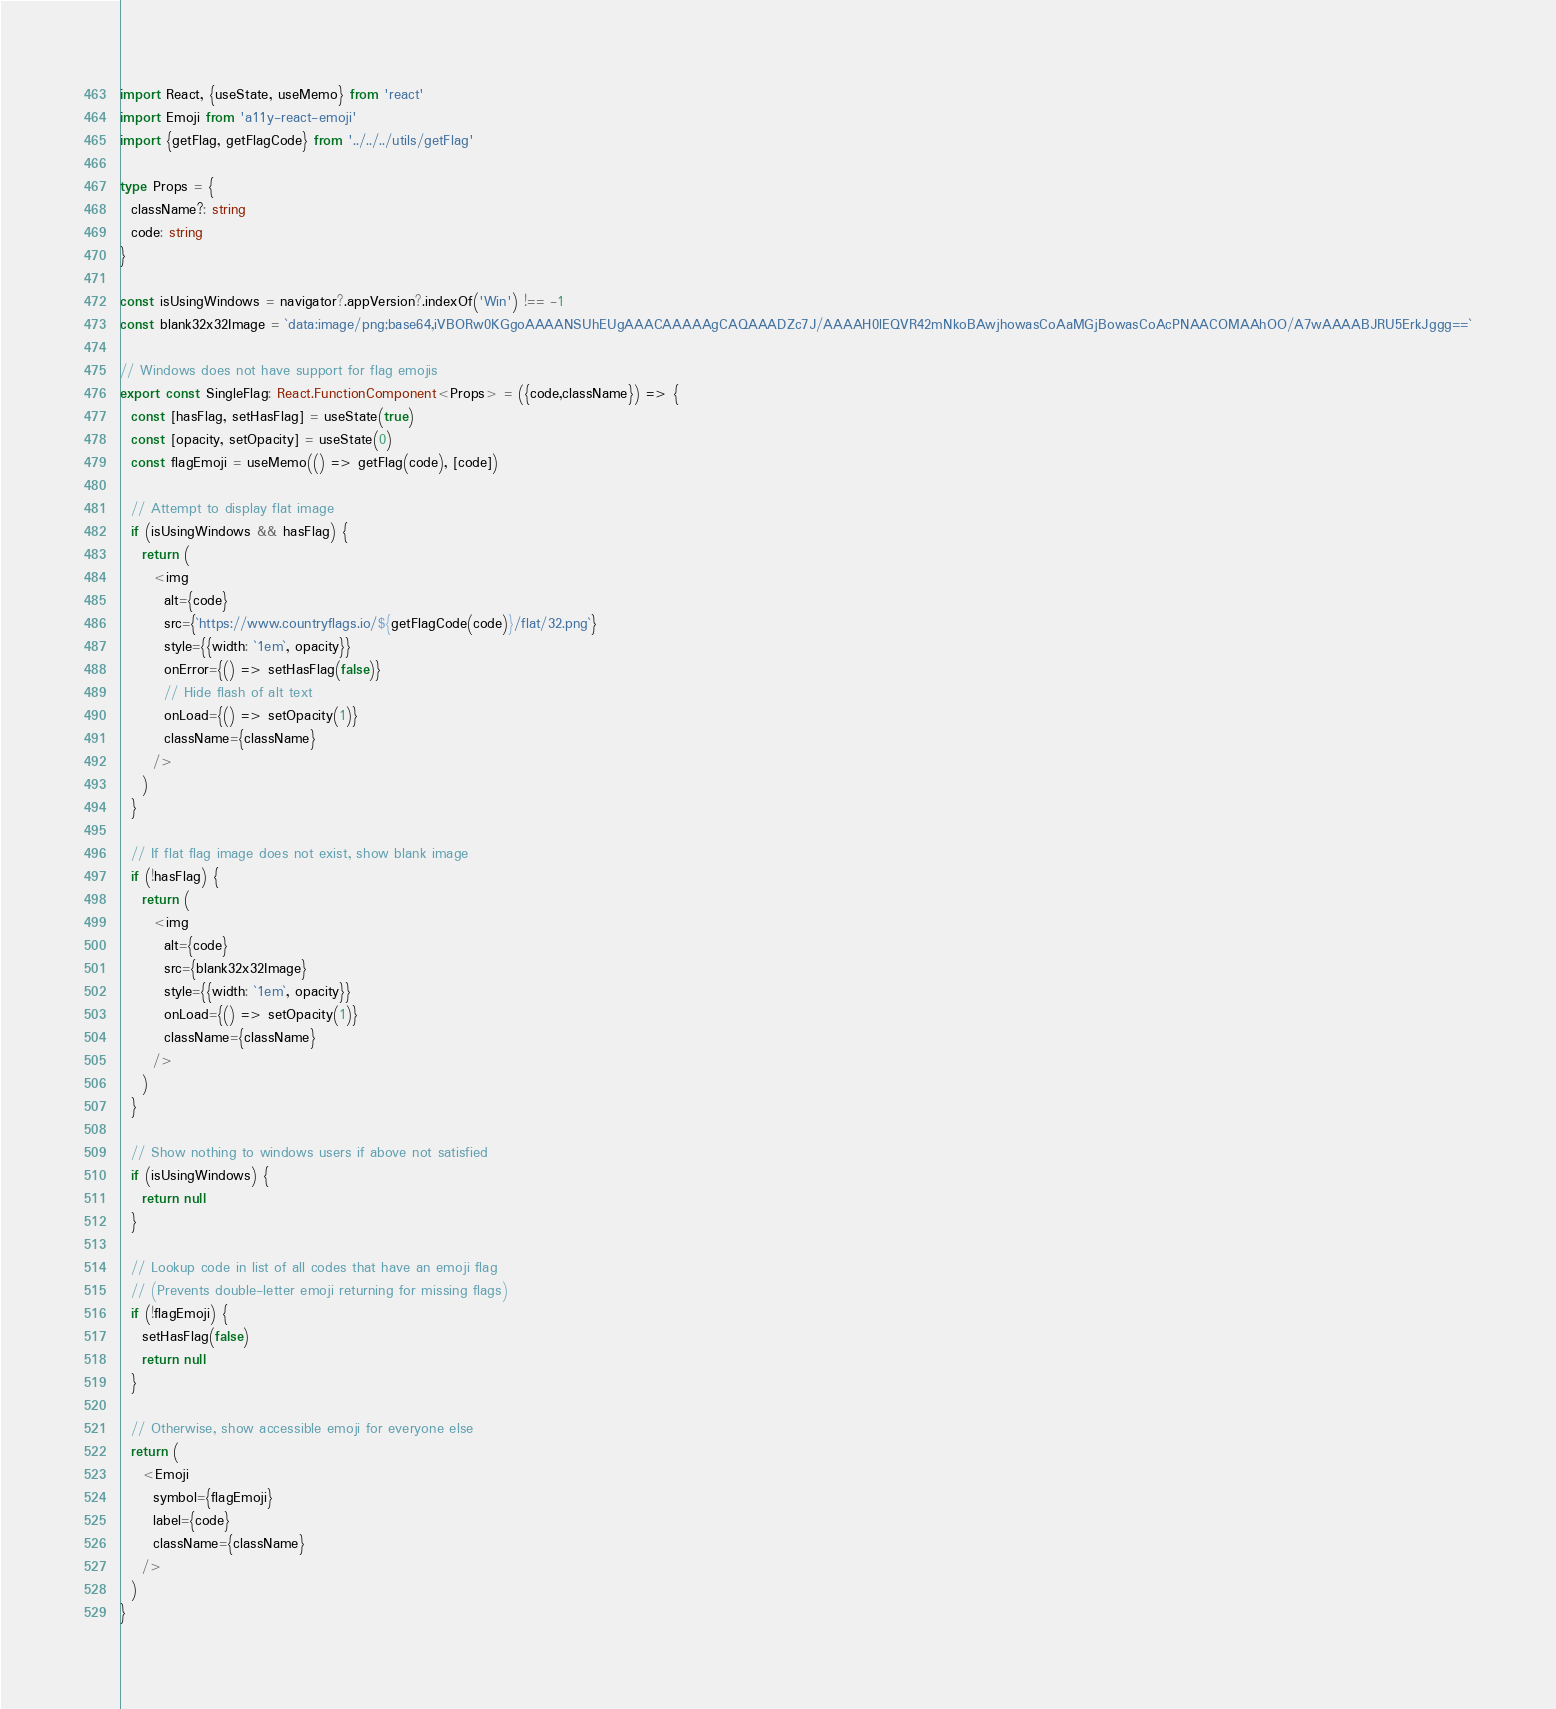<code> <loc_0><loc_0><loc_500><loc_500><_TypeScript_>import React, {useState, useMemo} from 'react'
import Emoji from 'a11y-react-emoji'
import {getFlag, getFlagCode} from '../../../utils/getFlag'

type Props = {
  className?: string
  code: string
}

const isUsingWindows = navigator?.appVersion?.indexOf('Win') !== -1
const blank32x32Image = `data:image/png;base64,iVBORw0KGgoAAAANSUhEUgAAACAAAAAgCAQAAADZc7J/AAAAH0lEQVR42mNkoBAwjhowasCoAaMGjBowasCoAcPNAACOMAAhOO/A7wAAAABJRU5ErkJggg==`

// Windows does not have support for flag emojis
export const SingleFlag: React.FunctionComponent<Props> = ({code,className}) => {
  const [hasFlag, setHasFlag] = useState(true)
  const [opacity, setOpacity] = useState(0)
  const flagEmoji = useMemo(() => getFlag(code), [code])

  // Attempt to display flat image
  if (isUsingWindows && hasFlag) {
    return (
      <img
        alt={code}
        src={`https://www.countryflags.io/${getFlagCode(code)}/flat/32.png`}
        style={{width: `1em`, opacity}}
        onError={() => setHasFlag(false)}
        // Hide flash of alt text
        onLoad={() => setOpacity(1)}
        className={className}
      />
    )
  }

  // If flat flag image does not exist, show blank image
  if (!hasFlag) {
    return (
      <img
        alt={code}
        src={blank32x32Image}
        style={{width: `1em`, opacity}}
        onLoad={() => setOpacity(1)}
        className={className}
      />
    )
  }

  // Show nothing to windows users if above not satisfied
  if (isUsingWindows) {
    return null
  }

  // Lookup code in list of all codes that have an emoji flag
  // (Prevents double-letter emoji returning for missing flags)
  if (!flagEmoji) {
    setHasFlag(false)
    return null
  }

  // Otherwise, show accessible emoji for everyone else
  return (
    <Emoji
      symbol={flagEmoji}
      label={code}
      className={className}
    />
  )
}
</code> 